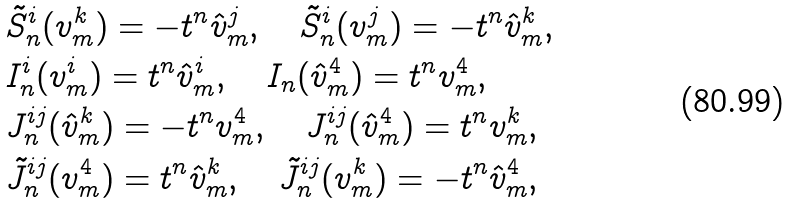Convert formula to latex. <formula><loc_0><loc_0><loc_500><loc_500>& \tilde { S } _ { n } ^ { i } ( { v } _ { m } ^ { k } ) = - t ^ { n } \hat { v } _ { m } ^ { j } , \quad \tilde { S } _ { n } ^ { i } ( { v } _ { m } ^ { j } ) = - t ^ { n } \hat { v } _ { m } ^ { k } , \\ & I _ { n } ^ { i } ( { v } _ { m } ^ { i } ) = t ^ { n } \hat { v } _ { m } ^ { i } , \quad I _ { n } ( \hat { v } _ { m } ^ { 4 } ) = t ^ { n } { v } _ { m } ^ { 4 } , \\ & J _ { n } ^ { i j } ( \hat { v } _ { m } ^ { k } ) = - t ^ { n } { v } _ { m } ^ { 4 } , \quad J _ { n } ^ { i j } ( \hat { v } _ { m } ^ { 4 } ) = t ^ { n } { v } _ { m } ^ { k } , \\ & \tilde { J } _ { n } ^ { i j } ( { v } _ { m } ^ { 4 } ) = t ^ { n } \hat { v } _ { m } ^ { k } , \quad \tilde { J } _ { n } ^ { i j } ( { v } _ { m } ^ { k } ) = - t ^ { n } \hat { v } _ { m } ^ { 4 } ,</formula> 